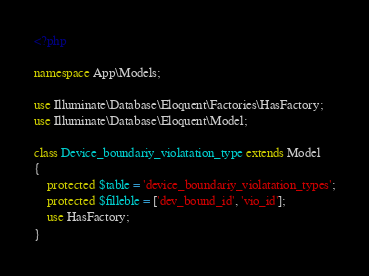<code> <loc_0><loc_0><loc_500><loc_500><_PHP_><?php

namespace App\Models;

use Illuminate\Database\Eloquent\Factories\HasFactory;
use Illuminate\Database\Eloquent\Model;

class Device_boundariy_violatation_type extends Model
{
    protected $table = 'device_boundariy_violatation_types';
    protected $filleble = ['dev_bound_id', 'vio_id'];
    use HasFactory;
}
</code> 